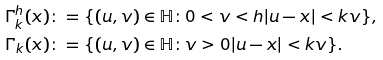Convert formula to latex. <formula><loc_0><loc_0><loc_500><loc_500>\Gamma _ { k } ^ { h } ( x ) & \colon = \{ ( u , v ) \in \mathbb { H } \colon 0 < v < h | u - x | < k v \} , \\ \Gamma _ { k } ( x ) & \colon = \{ ( u , v ) \in \mathbb { H } \colon v > 0 | u - x | < k v \} .</formula> 